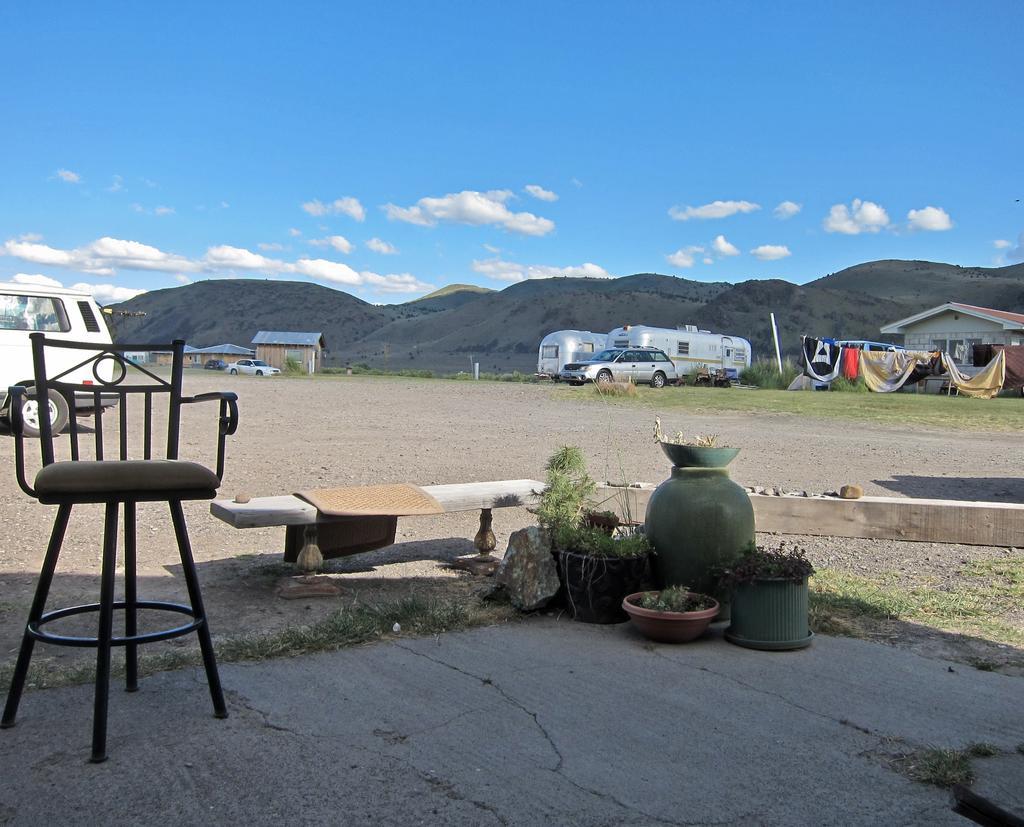In one or two sentences, can you explain what this image depicts? This picture shows an open space where we see Blue cloudy sky and cubicles parked can we see a house and chair and few plants 